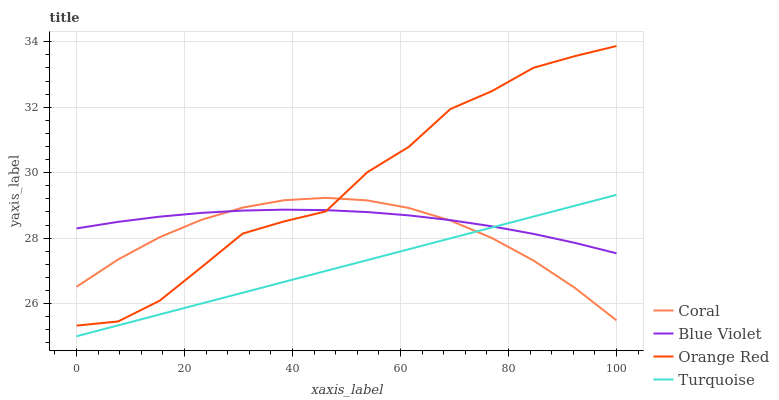Does Turquoise have the minimum area under the curve?
Answer yes or no. Yes. Does Orange Red have the maximum area under the curve?
Answer yes or no. Yes. Does Orange Red have the minimum area under the curve?
Answer yes or no. No. Does Turquoise have the maximum area under the curve?
Answer yes or no. No. Is Turquoise the smoothest?
Answer yes or no. Yes. Is Orange Red the roughest?
Answer yes or no. Yes. Is Orange Red the smoothest?
Answer yes or no. No. Is Turquoise the roughest?
Answer yes or no. No. Does Turquoise have the lowest value?
Answer yes or no. Yes. Does Orange Red have the lowest value?
Answer yes or no. No. Does Orange Red have the highest value?
Answer yes or no. Yes. Does Turquoise have the highest value?
Answer yes or no. No. Is Turquoise less than Orange Red?
Answer yes or no. Yes. Is Orange Red greater than Turquoise?
Answer yes or no. Yes. Does Blue Violet intersect Turquoise?
Answer yes or no. Yes. Is Blue Violet less than Turquoise?
Answer yes or no. No. Is Blue Violet greater than Turquoise?
Answer yes or no. No. Does Turquoise intersect Orange Red?
Answer yes or no. No. 